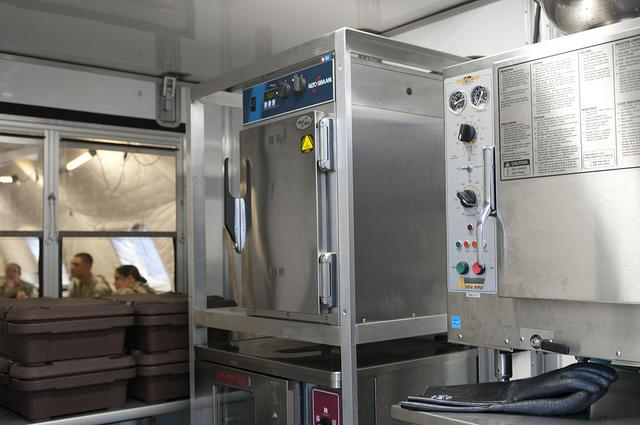What type of kitchen is this?

Choices:
A) island
B) residential
C) commercial
D) galley commercial 